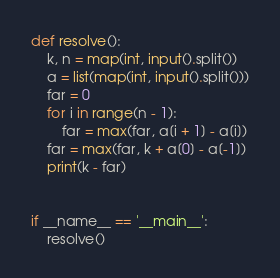Convert code to text. <code><loc_0><loc_0><loc_500><loc_500><_Python_>def resolve():
    k, n = map(int, input().split())
    a = list(map(int, input().split()))
    far = 0
    for i in range(n - 1):
        far = max(far, a[i + 1] - a[i])
    far = max(far, k + a[0] - a[-1])
    print(k - far)


if __name__ == '__main__':
    resolve()
</code> 